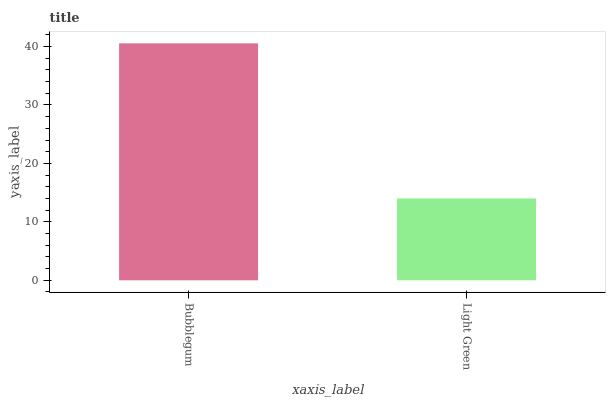Is Light Green the minimum?
Answer yes or no. Yes. Is Bubblegum the maximum?
Answer yes or no. Yes. Is Light Green the maximum?
Answer yes or no. No. Is Bubblegum greater than Light Green?
Answer yes or no. Yes. Is Light Green less than Bubblegum?
Answer yes or no. Yes. Is Light Green greater than Bubblegum?
Answer yes or no. No. Is Bubblegum less than Light Green?
Answer yes or no. No. Is Bubblegum the high median?
Answer yes or no. Yes. Is Light Green the low median?
Answer yes or no. Yes. Is Light Green the high median?
Answer yes or no. No. Is Bubblegum the low median?
Answer yes or no. No. 